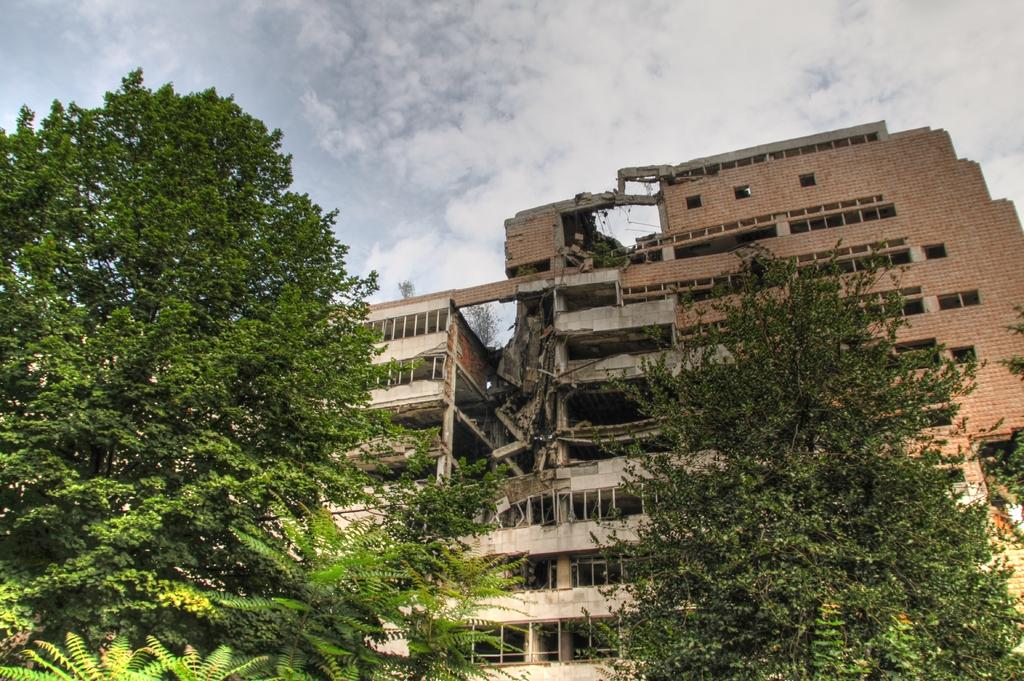What type of natural elements can be seen in the image? There are trees in the image. What type of man-made structure is present in the image? There is a building in the image. What is visible in the background of the image? The sky is visible in the background of the image. How would you describe the sky in the image? The sky appears to be cloudy. What type of string is used to create the clouds in the image? There is no string used to create the clouds in the image; the clouds are a natural part of the sky. How does the building's acoustics affect the sound of the trees in the image? The building's acoustics do not affect the sound of the trees in the image, as the image does not depict any sounds or audible elements. 